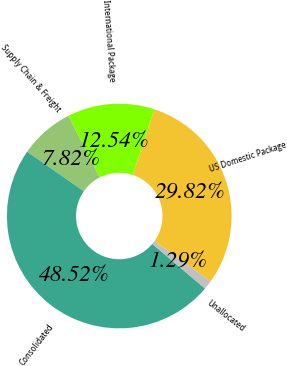Convert chart. <chart><loc_0><loc_0><loc_500><loc_500><pie_chart><fcel>US Domestic Package<fcel>International Package<fcel>Supply Chain & Freight<fcel>Consolidated<fcel>Unallocated<nl><fcel>29.82%<fcel>12.54%<fcel>7.82%<fcel>48.52%<fcel>1.29%<nl></chart> 